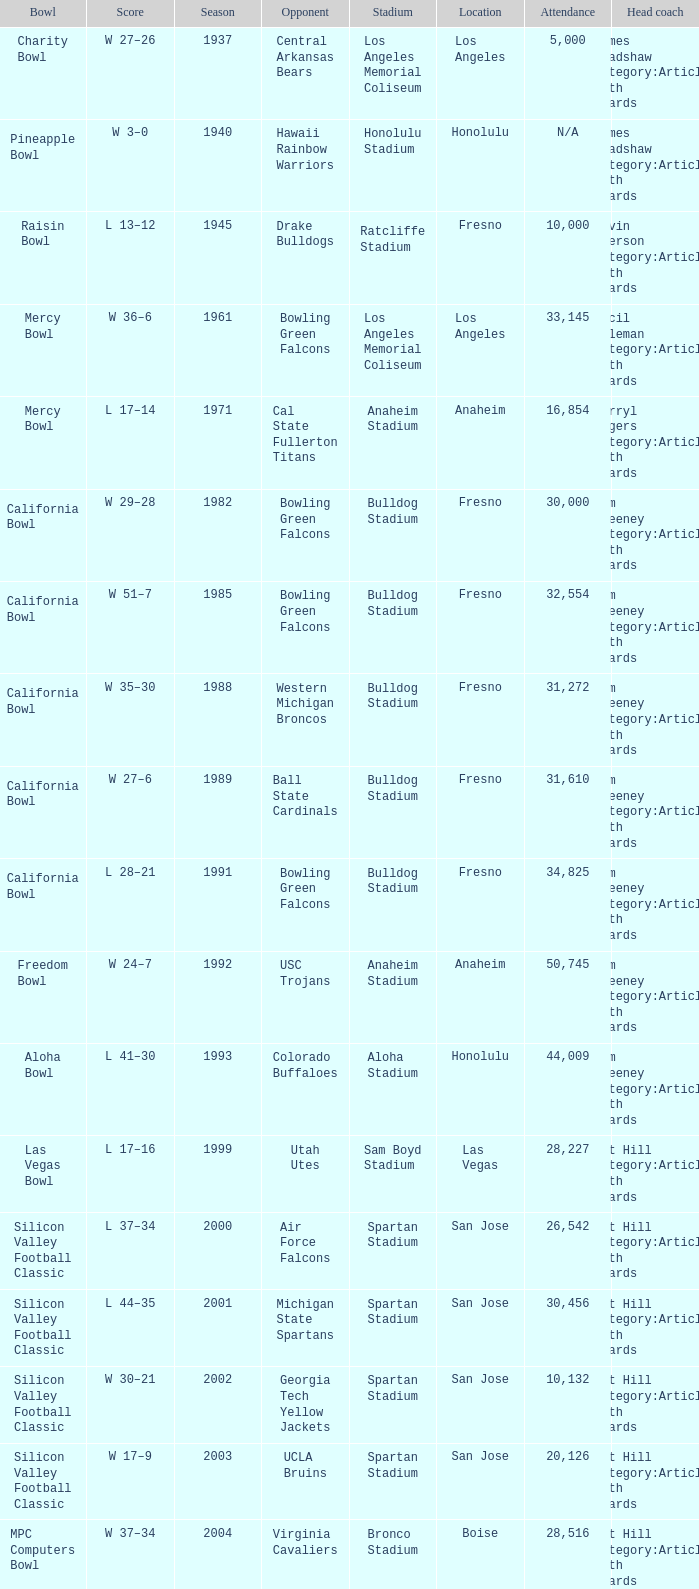Where was the California bowl played with 30,000 attending? Fresno. 